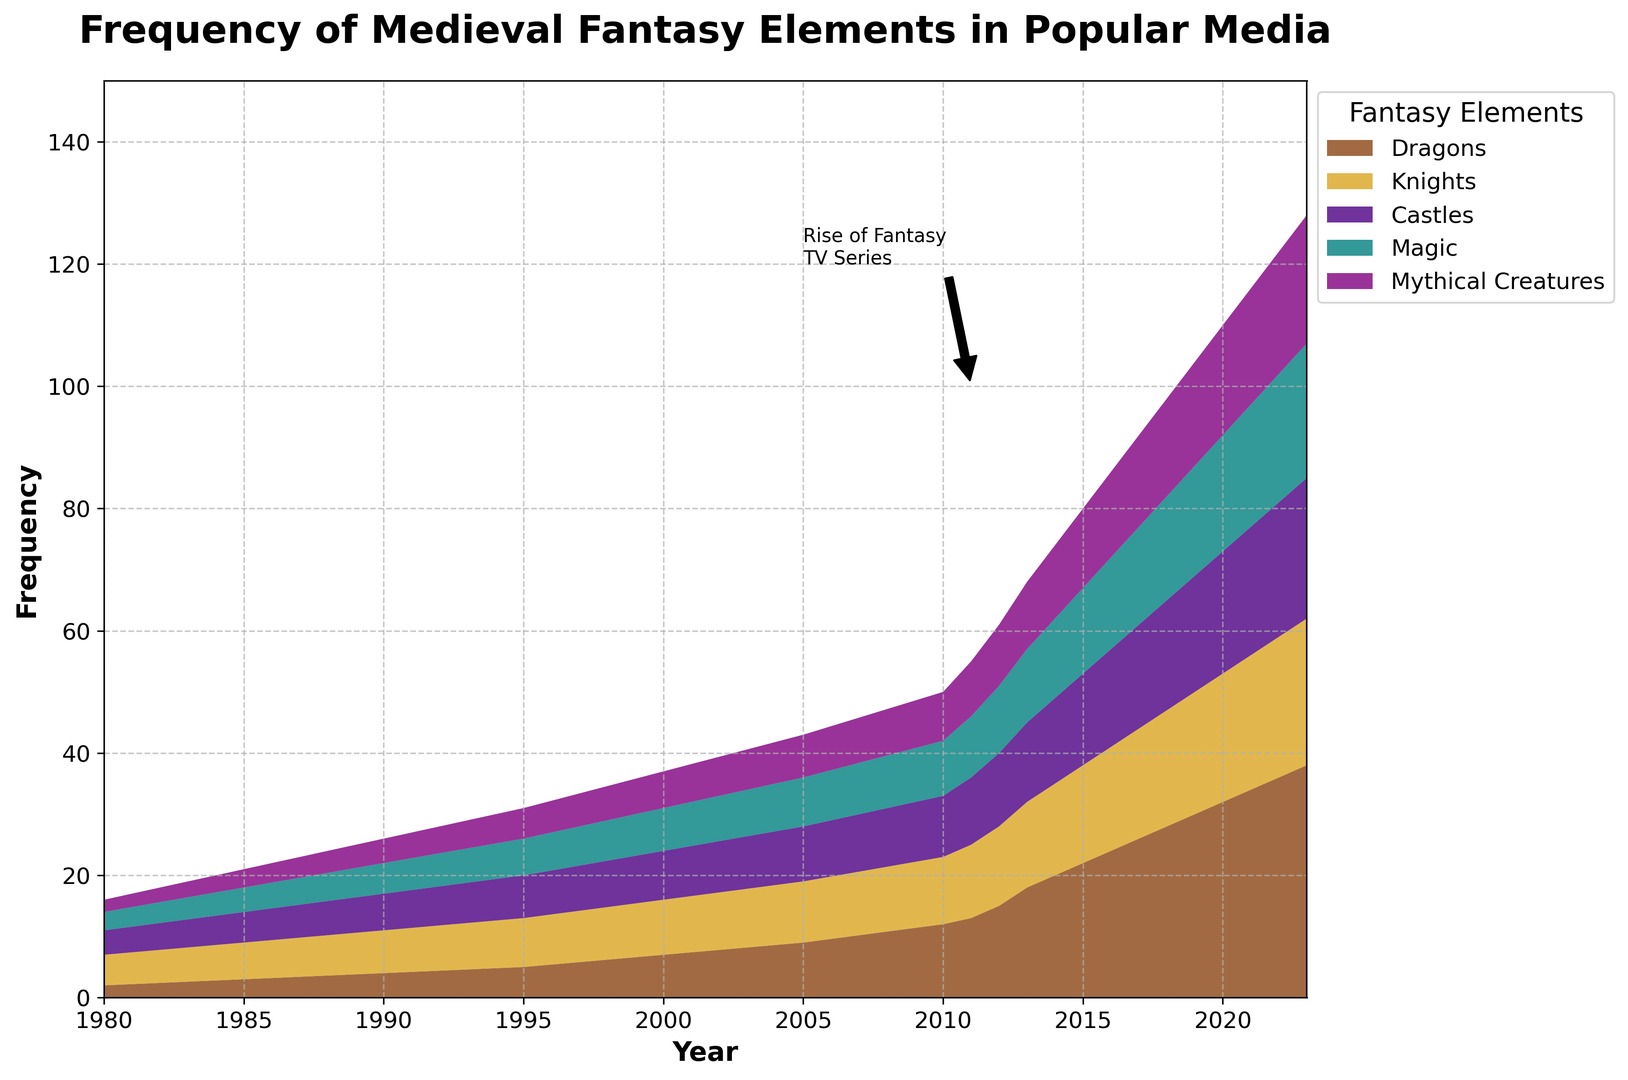Which fantasy element shows the highest increase from 2000 to 2023? To find the highest increase, we look at the initial and final values for each element from 2000 to 2023. Dragons increased from 7 to 38 (+31), Knights from 9 to 24 (+15), Castles from 8 to 23 (+15), Magic from 7 to 22 (+15), and Mythical Creatures from 6 to 21 (+15). Therefore, Dragons show the highest increase.
Answer: Dragons What is the combined frequency of Dragons and Castles in 2010? To find the combined frequency, add the values of Dragons and Castles in 2010. Dragons are 12 and Castles are 10. So, the combined frequency is 12 + 10 = 22.
Answer: 22 Which year marks the beginning of a notable rise in the frequency of all fantasy elements? The annotated rise of Fantasy TV Series starts from around 2011, marked visually in the chart by an arrow and annotation.
Answer: 2011 In 2020, does the frequency of Magic surpass Knights? In 2020, Magic frequency is 19, and Knights frequency is 21. Since 21 is greater than 19, Knights' frequency surpasses Magic.
Answer: No Which fantasy element consistently shows the lowest frequency from 1980 to 2023? By inspecting the chart, Mythical Creatures consistently show the lowest frequency throughout the time period.
Answer: Mythical Creatures What is the total frequency of all fantasy elements combined in 1985? Sum the frequencies of all elements in 1985: Dragons (3) + Knights (6) + Castles (5) + Magic (4) + Mythical Creatures (3) = 21.
Answer: 21 Between 2010 and 2015, which element had the steepest increase in frequency? Check the frequency changes between 2010 and 2015 for each element: Dragons increased from 12 to 22 (+10), Knights from 11 to 16 (+5), Castles from 10 to 15 (+5), Magic from 9 to 14 (+5), and Mythical Creatures from 8 to 13 (+5). Dragons had the steepest increase.
Answer: Dragons In 1995, how many times more frequent were Knights compared to Mythical Creatures? In 1995, Knights frequency was 8, and Mythical Creatures was 5. To find how many times more frequent, divide 8 by 5, which is 1.6 times.
Answer: 1.6 times What is the average frequency of all fantasy elements in 2022? First, sum the frequencies of all elements in 2022: Dragons (36) + Knights (23) + Castles (22) + Magic (21) + Mythical Creatures (20) = 122. Then, calculate the average: 122 / 5 = 24.4.
Answer: 24.4 